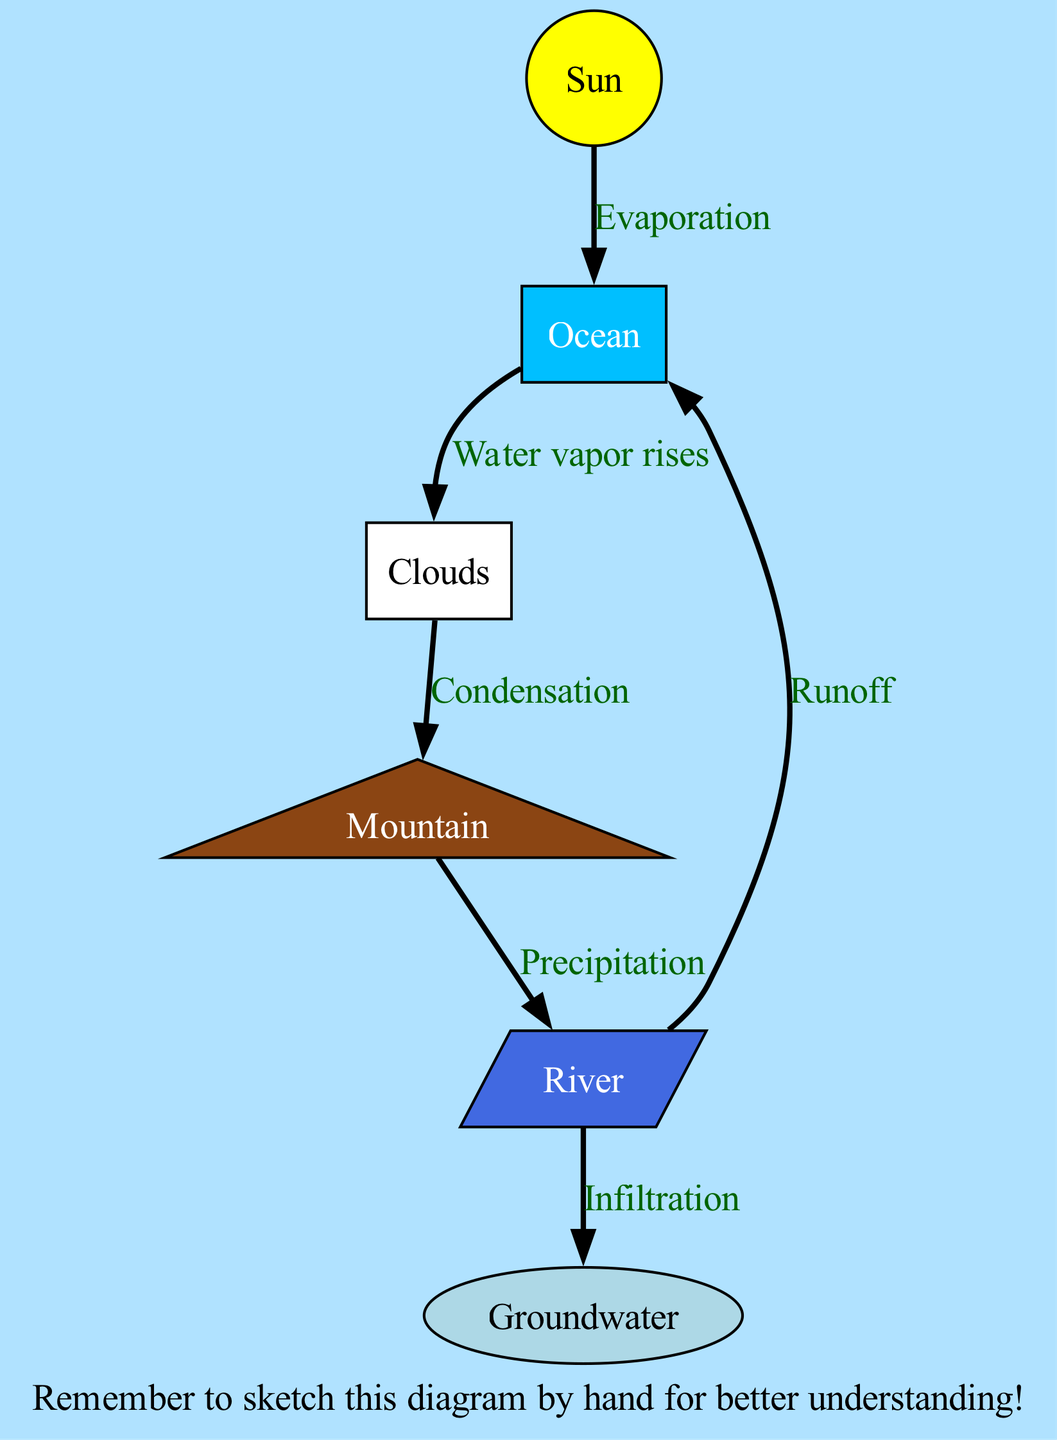What is the starting point of evaporation in the diagram? The diagram shows that evaporation begins at the "Ocean," which is indicated as the node where the Sun's energy drives the process.
Answer: Ocean How many nodes are present in the diagram? By counting the nodes listed, we find that there are a total of six distinct nodes: Sun, Ocean, Clouds, Mountain, River, and Groundwater.
Answer: 6 Which process follows condensation in the water cycle shown in the diagram? After condensation occurs in the Clouds, the next step indicated is "Precipitation," which connects the Clouds to the Mountain.
Answer: Precipitation What is the relationship between the River and the Ocean in the diagram? The River has an edge going to the Ocean labeled "Runoff," which indicates that water flows back into the Ocean from the River.
Answer: Runoff Which node is associated with rainfall in the water cycle? The process that represents rainfall is called "Precipitation," occurring at the Mountain, which is the node where precipitation is indicated to happen.
Answer: Mountain What two processes occur after water leaves the Clouds? After water leaves the Clouds, it undergoes "Precipitation" toward the Mountain and "Water vapor rises" toward the Clouds, indicating initial movement back toward evaporation.
Answer: Precipitation and Water vapor rises Describe where infiltration occurs in relation to the River. Infiltration, the process of water moving into the ground, is indicated as flowing from the River to the Groundwater, highlighting how water can seep into the earth.
Answer: Groundwater What does the Sun contribute to the water cycle? The Sun provides energy that drives the process of "Evaporation," enabling water from the Ocean to transform into water vapor.
Answer: Evaporation How are the nodes linked by edges in the diagram? Each edge represents a process connecting nodes, such as the edge from Sun to Ocean for evaporation and from Mountain to River for precipitation. These edges visually link the cycle's steps.
Answer: Various processes 